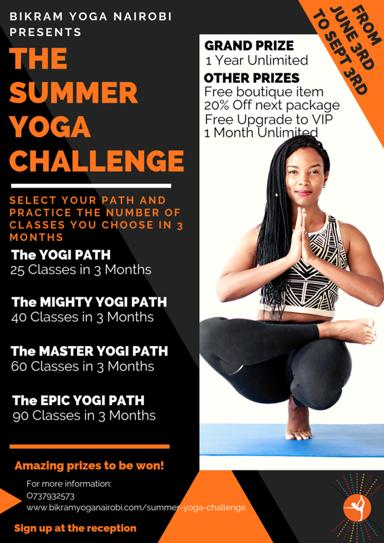What is the event being advertised in the image? The event being advertised is the exhilarating Summer Yoga Challenge hosted by Bikram Yoga Nairobi. This thrilling opportunity invites participants to challenge themselves and enhance their yoga practice over the summer, offering multiple paths for involvement. 